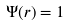<formula> <loc_0><loc_0><loc_500><loc_500>\Psi ( r ) = 1</formula> 